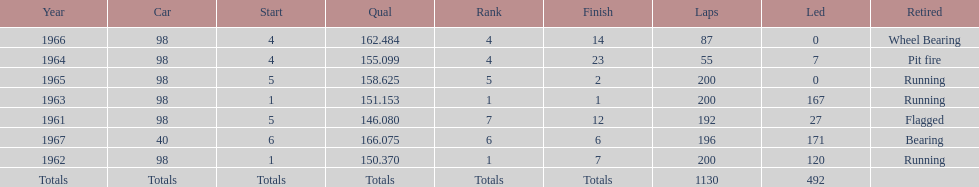Would you mind parsing the complete table? {'header': ['Year', 'Car', 'Start', 'Qual', 'Rank', 'Finish', 'Laps', 'Led', 'Retired'], 'rows': [['1966', '98', '4', '162.484', '4', '14', '87', '0', 'Wheel Bearing'], ['1964', '98', '4', '155.099', '4', '23', '55', '7', 'Pit fire'], ['1965', '98', '5', '158.625', '5', '2', '200', '0', 'Running'], ['1963', '98', '1', '151.153', '1', '1', '200', '167', 'Running'], ['1961', '98', '5', '146.080', '7', '12', '192', '27', 'Flagged'], ['1967', '40', '6', '166.075', '6', '6', '196', '171', 'Bearing'], ['1962', '98', '1', '150.370', '1', '7', '200', '120', 'Running'], ['Totals', 'Totals', 'Totals', 'Totals', 'Totals', 'Totals', '1130', '492', '']]} In which years did he lead the race the least? 1965, 1966. 